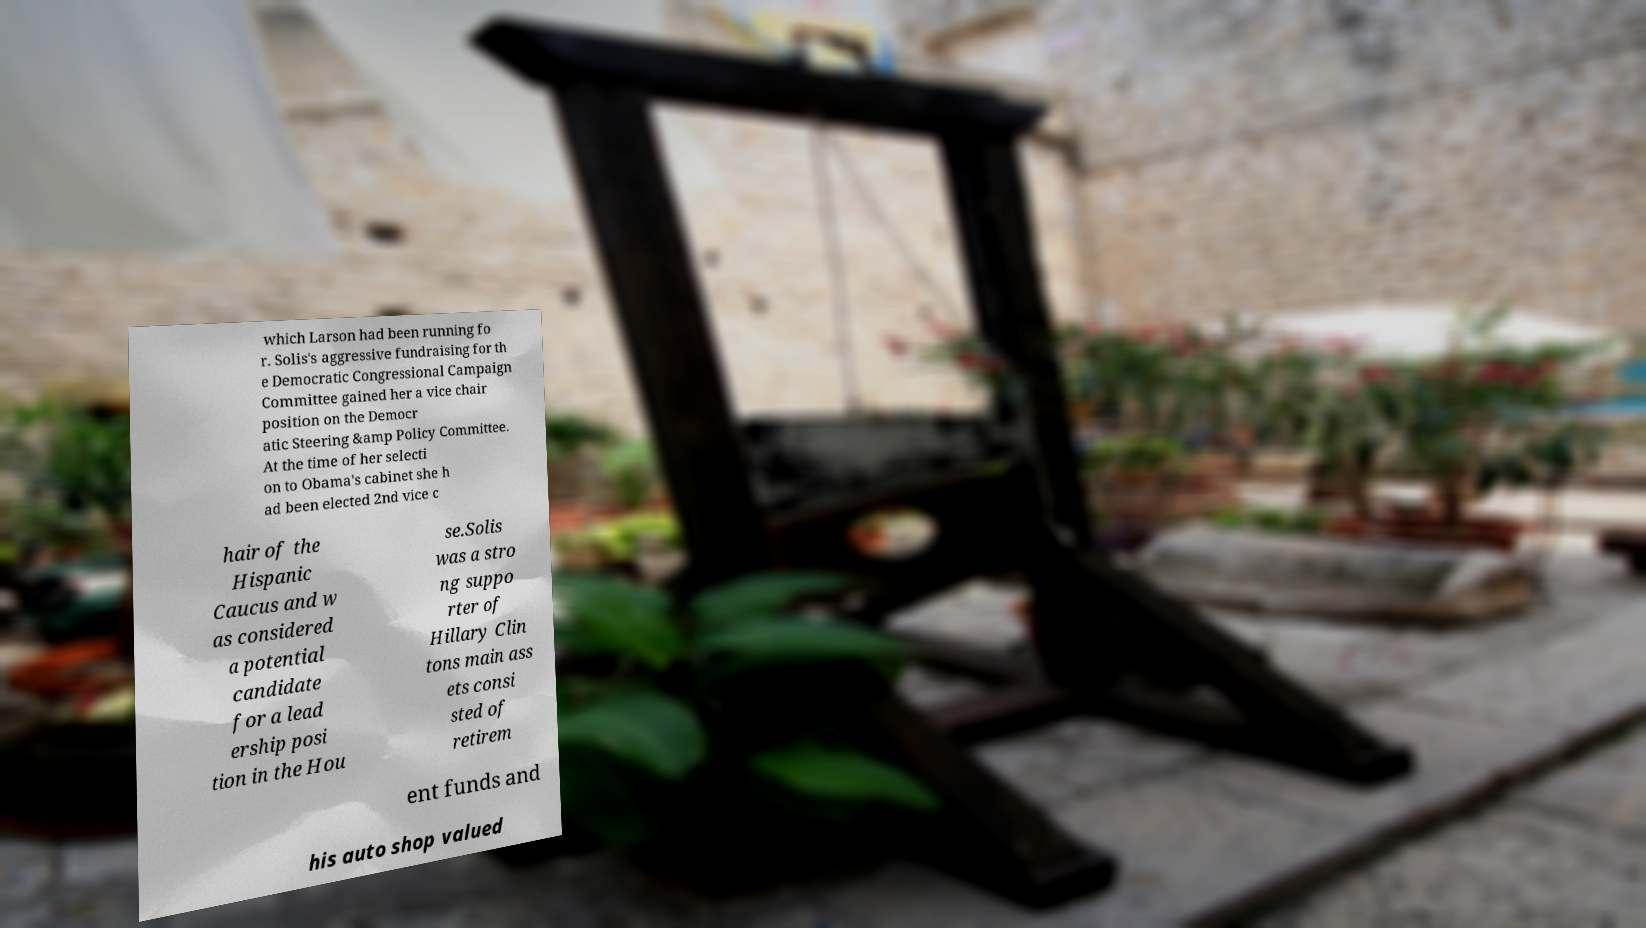For documentation purposes, I need the text within this image transcribed. Could you provide that? which Larson had been running fo r. Solis's aggressive fundraising for th e Democratic Congressional Campaign Committee gained her a vice chair position on the Democr atic Steering &amp Policy Committee. At the time of her selecti on to Obama's cabinet she h ad been elected 2nd vice c hair of the Hispanic Caucus and w as considered a potential candidate for a lead ership posi tion in the Hou se.Solis was a stro ng suppo rter of Hillary Clin tons main ass ets consi sted of retirem ent funds and his auto shop valued 